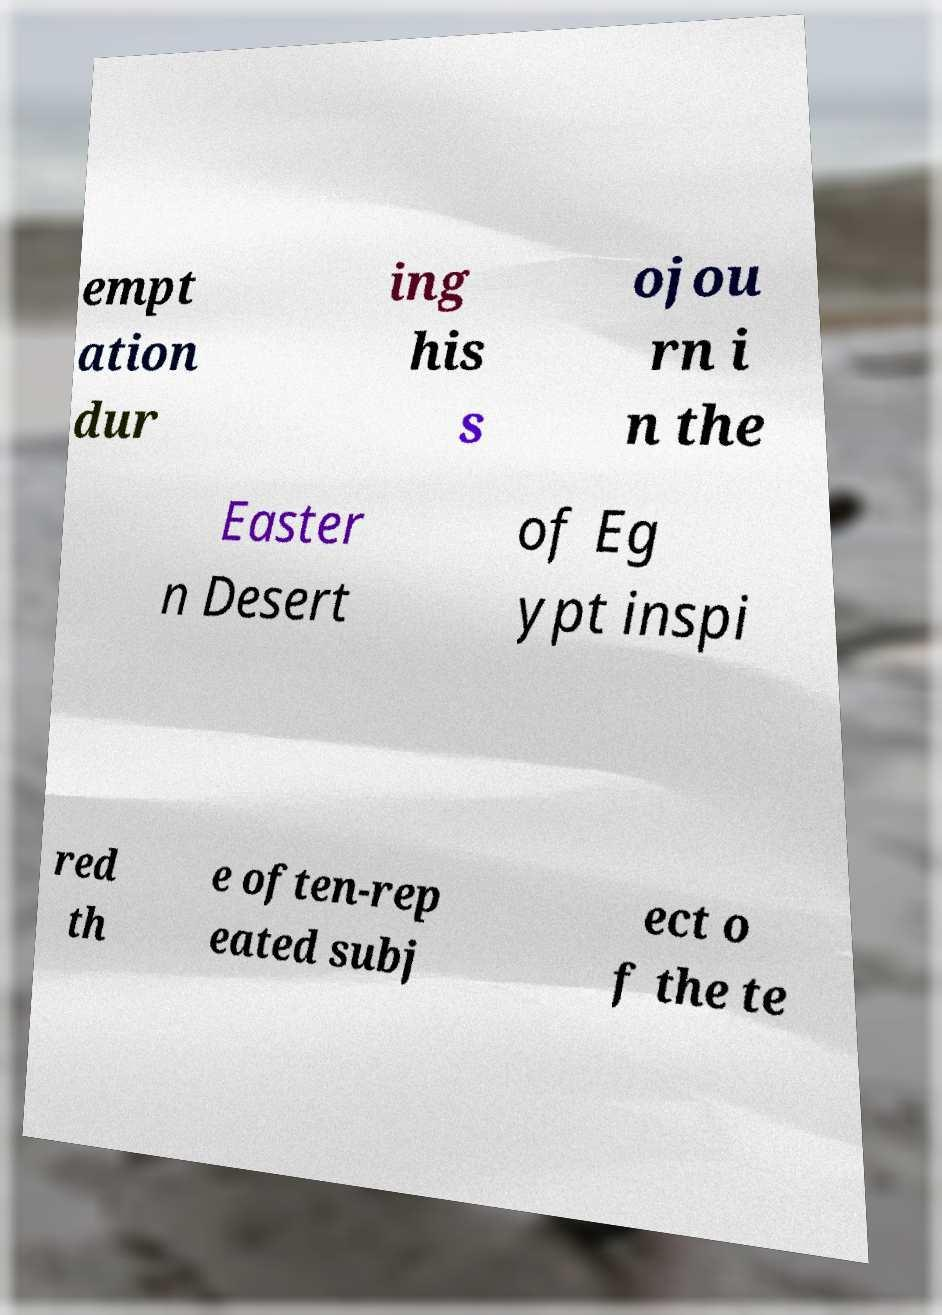For documentation purposes, I need the text within this image transcribed. Could you provide that? empt ation dur ing his s ojou rn i n the Easter n Desert of Eg ypt inspi red th e often-rep eated subj ect o f the te 